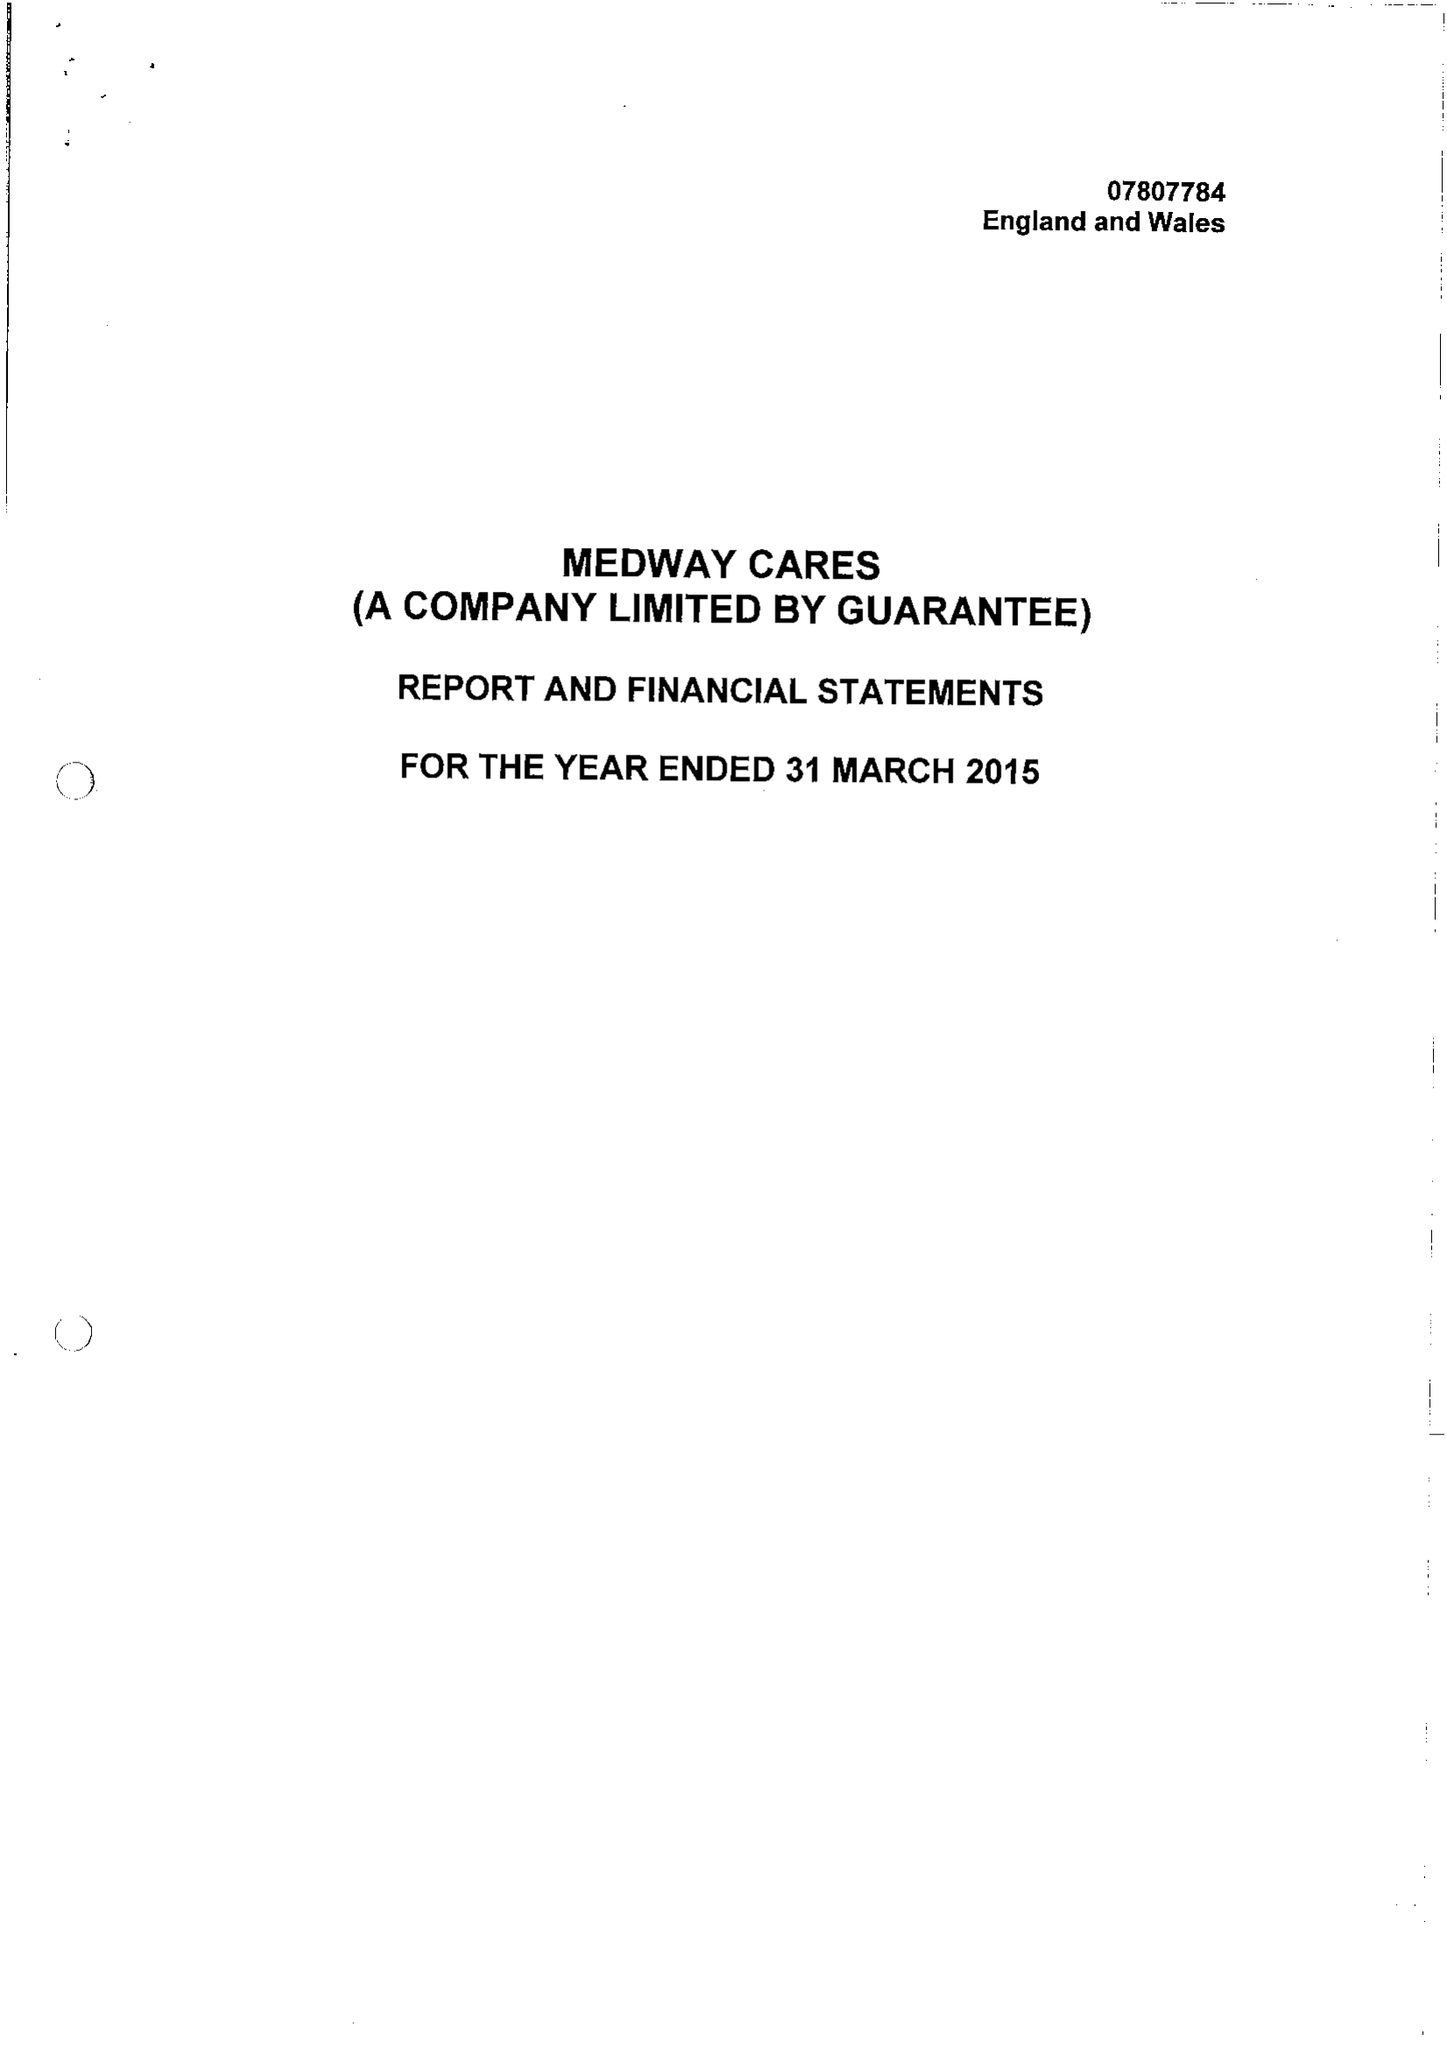What is the value for the spending_annually_in_british_pounds?
Answer the question using a single word or phrase. 59408.00 